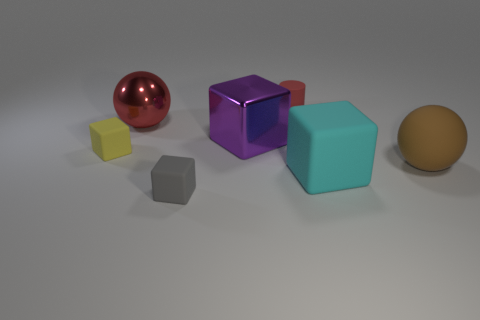Subtract 1 cubes. How many cubes are left? 3 Add 1 cyan matte blocks. How many objects exist? 8 Subtract all cubes. How many objects are left? 3 Add 5 large cyan things. How many large cyan things are left? 6 Add 7 small red shiny cubes. How many small red shiny cubes exist? 7 Subtract 1 gray blocks. How many objects are left? 6 Subtract all large cyan rubber objects. Subtract all large spheres. How many objects are left? 4 